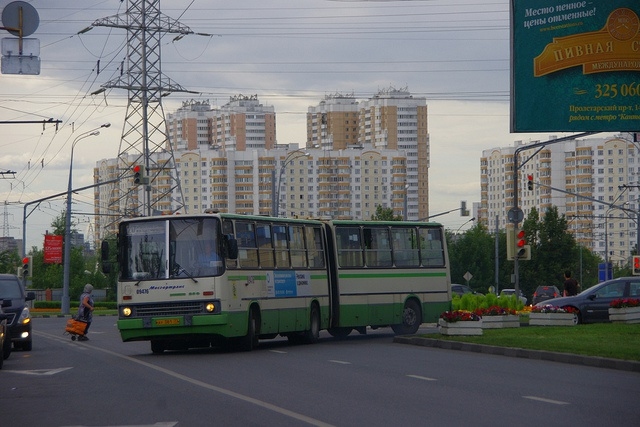Describe the objects in this image and their specific colors. I can see bus in gray, black, blue, and darkgreen tones, car in gray, black, and blue tones, truck in gray, black, and darkblue tones, car in gray, black, and darkblue tones, and potted plant in gray, black, and maroon tones in this image. 